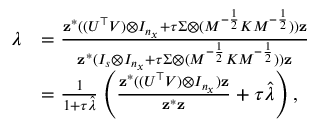Convert formula to latex. <formula><loc_0><loc_0><loc_500><loc_500>\begin{array} { r l } { \lambda } & { = \frac { z ^ { * } ( ( U ^ { \top } V ) \otimes I _ { n _ { x } } + \tau \Sigma \otimes ( M ^ { - \frac { 1 } { 2 } } K M ^ { - \frac { 1 } { 2 } } ) ) z } { z ^ { * } ( I _ { s } \otimes I _ { n _ { x } } + \tau \Sigma \otimes ( M ^ { - \frac { 1 } { 2 } } K M ^ { - \frac { 1 } { 2 } } ) ) z } } \\ & { = \frac { 1 } { 1 + \tau \hat { \lambda } } \left ( \frac { z ^ { * } ( ( U ^ { \top } V ) \otimes I _ { n _ { x } } ) z } { z ^ { * } z } + \tau \hat { \lambda } \right ) , } \end{array}</formula> 